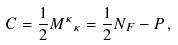<formula> <loc_0><loc_0><loc_500><loc_500>C = \frac { 1 } { 2 } { M ^ { \kappa } } _ { \kappa } = \frac { 1 } { 2 } N _ { F } - P \, ,</formula> 